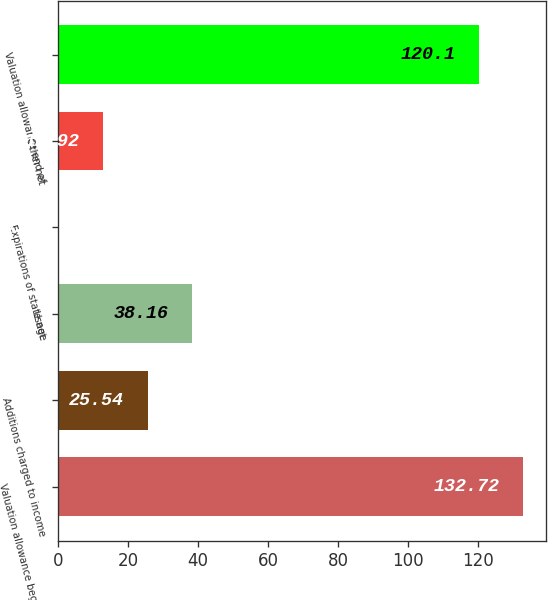Convert chart. <chart><loc_0><loc_0><loc_500><loc_500><bar_chart><fcel>Valuation allowance beginning<fcel>Additions charged to income<fcel>Usage<fcel>Expirations of state net<fcel>Other net<fcel>Valuation allowance end of<nl><fcel>132.72<fcel>25.54<fcel>38.16<fcel>0.3<fcel>12.92<fcel>120.1<nl></chart> 